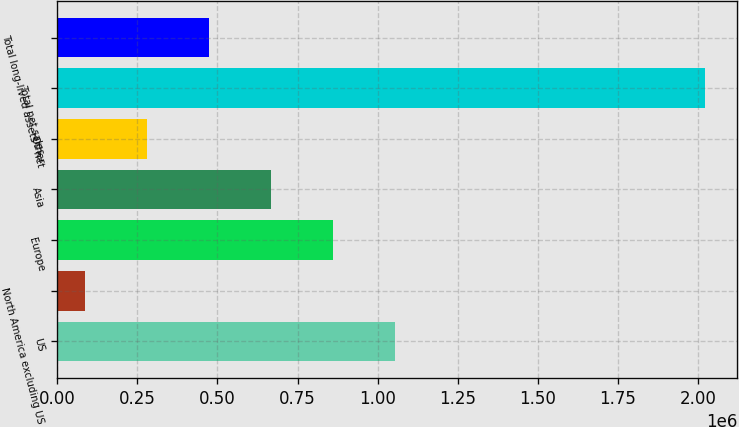<chart> <loc_0><loc_0><loc_500><loc_500><bar_chart><fcel>US<fcel>North America excluding US<fcel>Europe<fcel>Asia<fcel>Other<fcel>Total net sales<fcel>Total long-lived assets - net<nl><fcel>1.05326e+06<fcel>85852<fcel>859778<fcel>666297<fcel>279334<fcel>2.02067e+06<fcel>472815<nl></chart> 